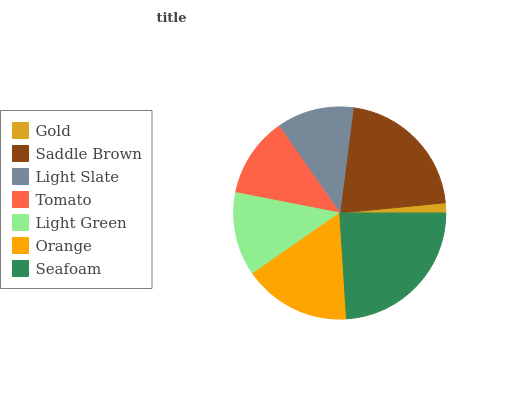Is Gold the minimum?
Answer yes or no. Yes. Is Seafoam the maximum?
Answer yes or no. Yes. Is Saddle Brown the minimum?
Answer yes or no. No. Is Saddle Brown the maximum?
Answer yes or no. No. Is Saddle Brown greater than Gold?
Answer yes or no. Yes. Is Gold less than Saddle Brown?
Answer yes or no. Yes. Is Gold greater than Saddle Brown?
Answer yes or no. No. Is Saddle Brown less than Gold?
Answer yes or no. No. Is Light Green the high median?
Answer yes or no. Yes. Is Light Green the low median?
Answer yes or no. Yes. Is Light Slate the high median?
Answer yes or no. No. Is Light Slate the low median?
Answer yes or no. No. 